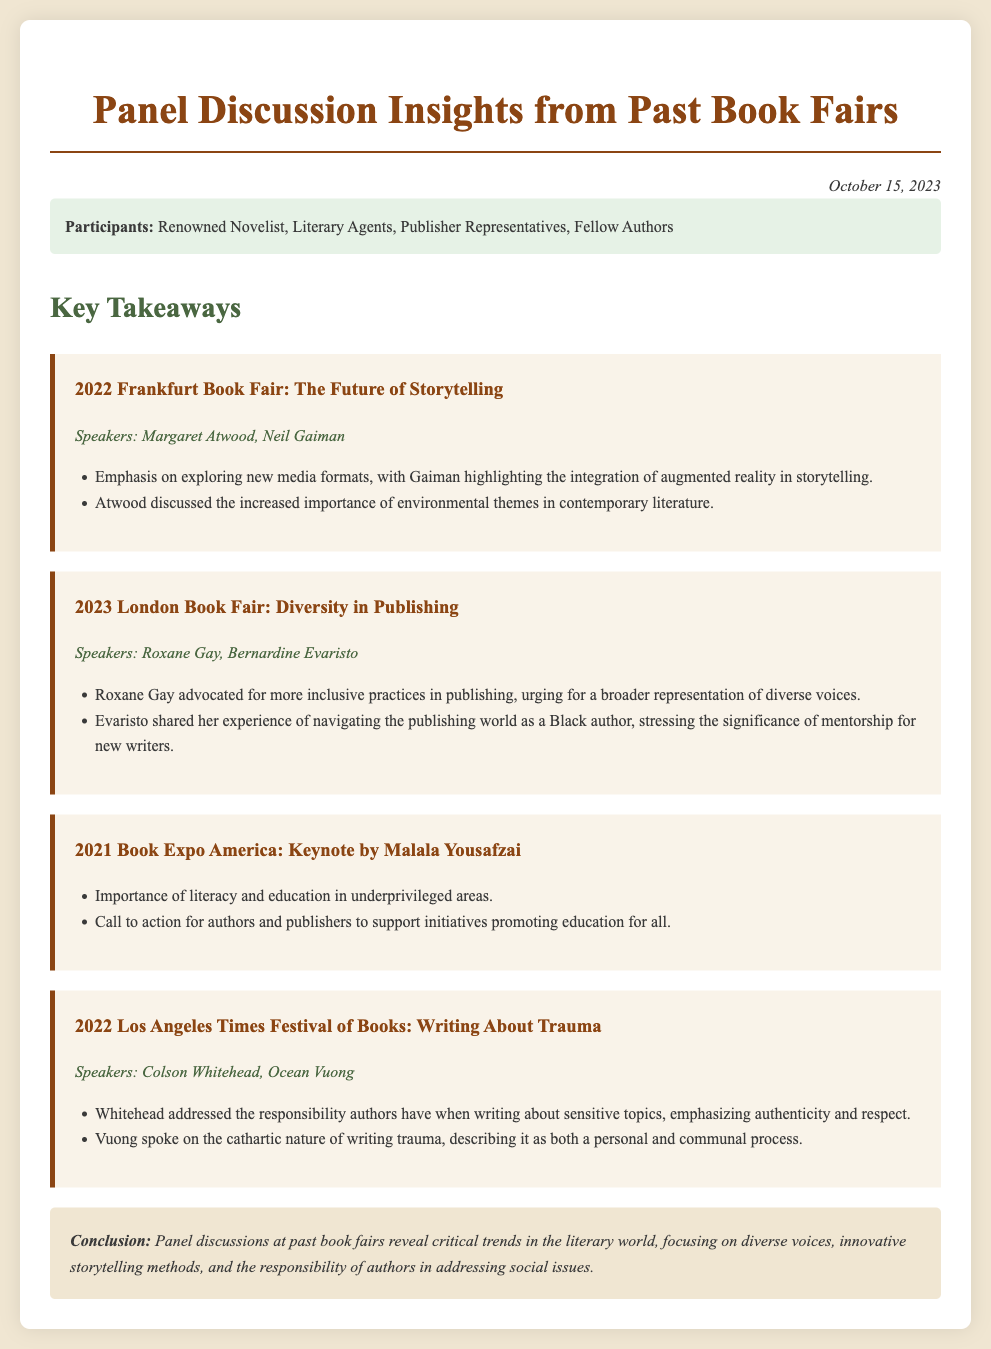What was the theme of the 2022 Frankfurt Book Fair? The document states that the theme was "The Future of Storytelling."
Answer: The Future of Storytelling Who spoke about environmental themes at the Frankfurt Book Fair? Margaret Atwood discussed the increased importance of environmental themes in contemporary literature.
Answer: Margaret Atwood In which year did Malala Yousafzai give a keynote speech? The document mentions the year 2021 for Malala Yousafzai's keynote speech.
Answer: 2021 What is a key topic discussed by Roxane Gay? Roxane Gay advocated for more inclusive practices in publishing.
Answer: Inclusive practices Which authors discussed writing about trauma at the 2022 Los Angeles Times Festival of Books? The document lists Colson Whitehead and Ocean Vuong as the authors who discussed this topic.
Answer: Colson Whitehead, Ocean Vuong What is one major responsibility of authors according to Colson Whitehead? The document states that Whitehead emphasized the responsibility authors have when writing about sensitive topics.
Answer: Responsibility What was a call to action made during Malala Yousafzai's keynote? The document indicates a call to action for authors and publishers to support initiatives promoting education for all.
Answer: Promote education for all What trend was emphasized in the conclusion of the document? The conclusion reveals critical trends focusing on diverse voices and innovative storytelling methods.
Answer: Diverse voices, innovative storytelling methods How many events are highlighted in the document? The document lists four events in total.
Answer: Four 